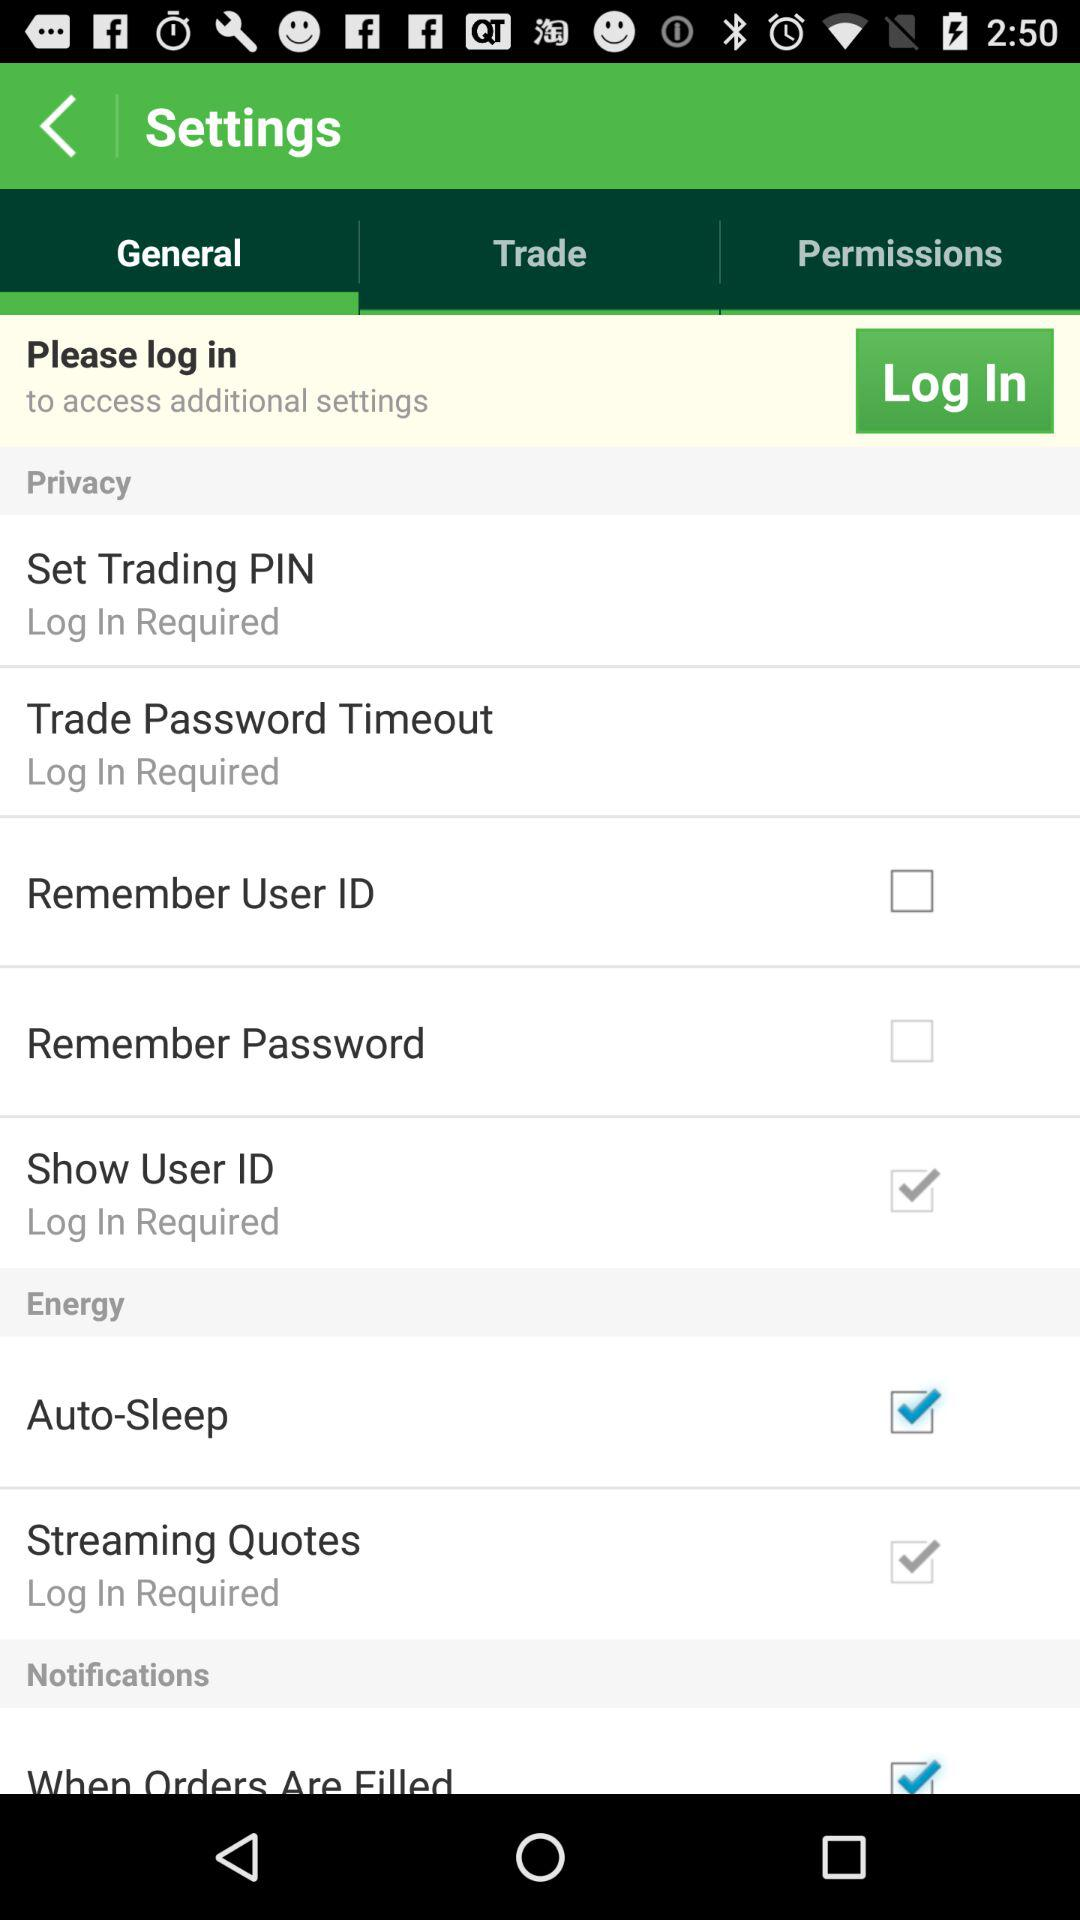What's the requirement for setting a trading PIN? The requirement is to log in. 